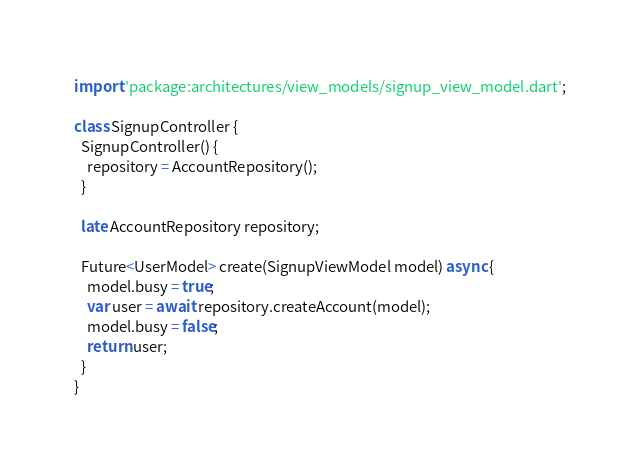Convert code to text. <code><loc_0><loc_0><loc_500><loc_500><_Dart_>import 'package:architectures/view_models/signup_view_model.dart';

class SignupController {
  SignupController() {
    repository = AccountRepository();
  }

  late AccountRepository repository;

  Future<UserModel> create(SignupViewModel model) async {
    model.busy = true;
    var user = await repository.createAccount(model);
    model.busy = false;
    return user;
  }
}
</code> 